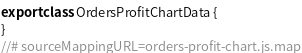Convert code to text. <code><loc_0><loc_0><loc_500><loc_500><_JavaScript_>export class OrdersProfitChartData {
}
//# sourceMappingURL=orders-profit-chart.js.map</code> 